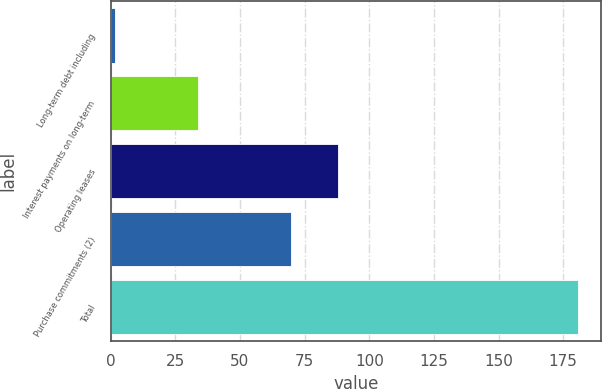Convert chart. <chart><loc_0><loc_0><loc_500><loc_500><bar_chart><fcel>Long-term debt including<fcel>Interest payments on long-term<fcel>Operating leases<fcel>Purchase commitments (2)<fcel>Total<nl><fcel>1.7<fcel>33.8<fcel>87.79<fcel>69.9<fcel>180.6<nl></chart> 